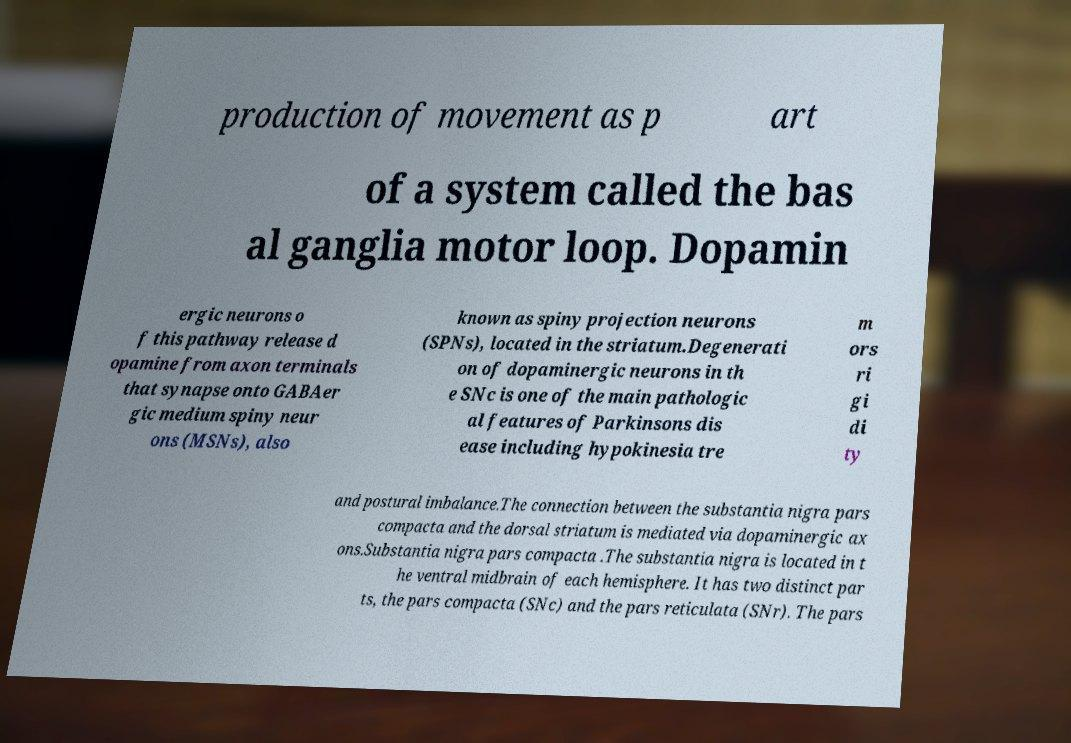What messages or text are displayed in this image? I need them in a readable, typed format. production of movement as p art of a system called the bas al ganglia motor loop. Dopamin ergic neurons o f this pathway release d opamine from axon terminals that synapse onto GABAer gic medium spiny neur ons (MSNs), also known as spiny projection neurons (SPNs), located in the striatum.Degenerati on of dopaminergic neurons in th e SNc is one of the main pathologic al features of Parkinsons dis ease including hypokinesia tre m ors ri gi di ty and postural imbalance.The connection between the substantia nigra pars compacta and the dorsal striatum is mediated via dopaminergic ax ons.Substantia nigra pars compacta .The substantia nigra is located in t he ventral midbrain of each hemisphere. It has two distinct par ts, the pars compacta (SNc) and the pars reticulata (SNr). The pars 